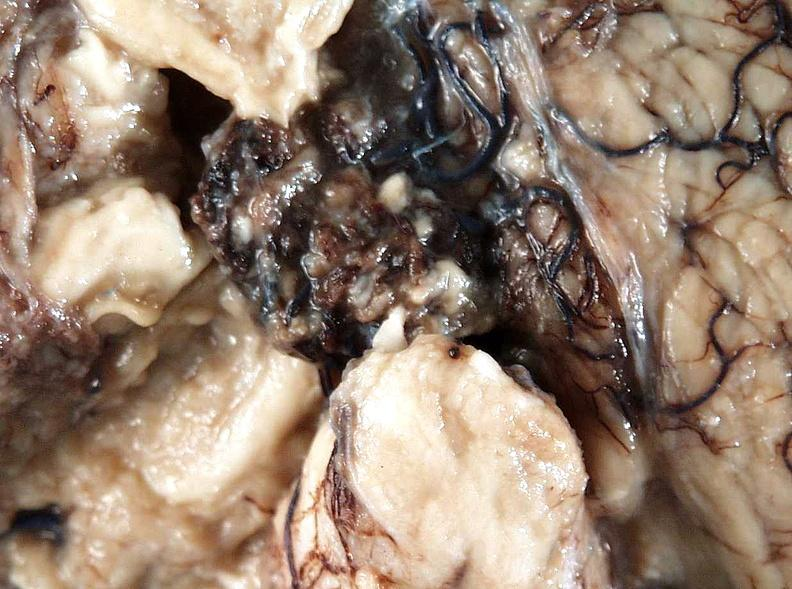what does this image show?
Answer the question using a single word or phrase. Brain 